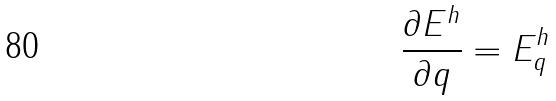Convert formula to latex. <formula><loc_0><loc_0><loc_500><loc_500>\frac { \partial E ^ { h } } { \partial q } = E _ { q } ^ { h }</formula> 